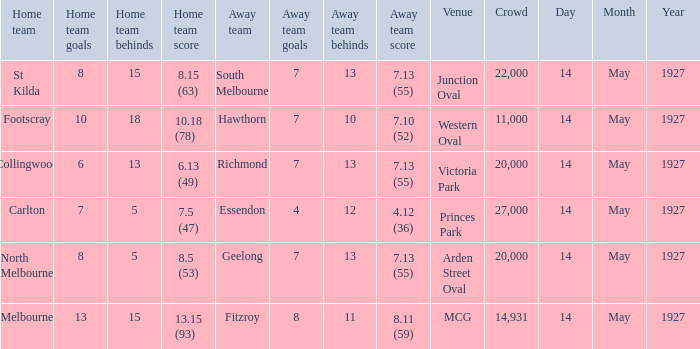Which venue hosted a home team with a score of 13.15 (93)? MCG. 